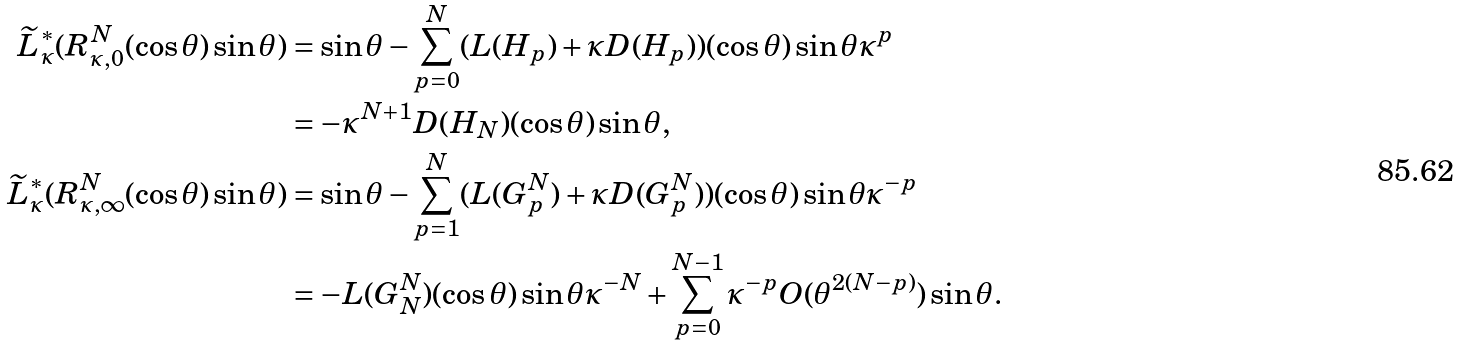Convert formula to latex. <formula><loc_0><loc_0><loc_500><loc_500>\widetilde { L } _ { \kappa } ^ { * } ( R ^ { N } _ { \kappa , 0 } ( \cos \theta ) \sin \theta ) & = \sin \theta - \sum _ { p = 0 } ^ { N } ( L ( H _ { p } ) + \kappa D ( H _ { p } ) ) ( \cos \theta ) \sin \theta \kappa ^ { p } \\ & = - \kappa ^ { N + 1 } D ( H _ { N } ) ( \cos \theta ) \sin \theta , \\ \widetilde { L } _ { \kappa } ^ { * } ( R ^ { N } _ { \kappa , \infty } ( \cos \theta ) \sin \theta ) & = \sin \theta - \sum _ { p = 1 } ^ { N } ( L ( G ^ { N } _ { p } ) + \kappa D ( G ^ { N } _ { p } ) ) ( \cos \theta ) \sin \theta \kappa ^ { - p } \\ & = - L ( G ^ { N } _ { N } ) ( \cos \theta ) \sin \theta \kappa ^ { - N } + \sum _ { p = 0 } ^ { N - 1 } \kappa ^ { - p } O ( \theta ^ { 2 ( N - p ) } ) \sin \theta .</formula> 